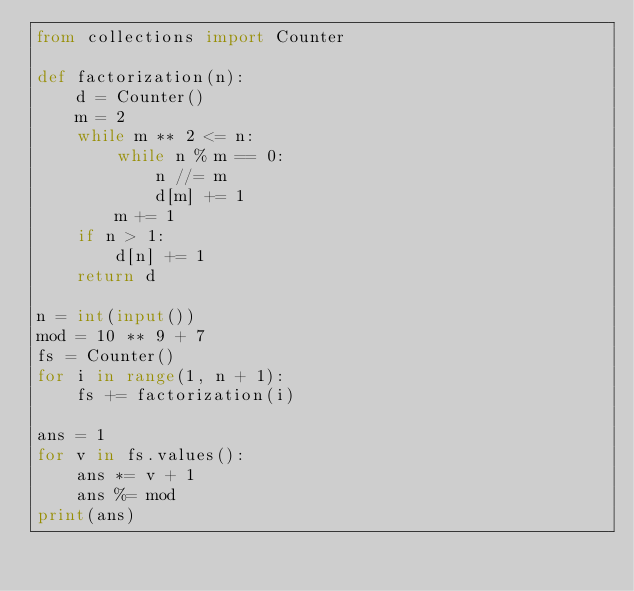Convert code to text. <code><loc_0><loc_0><loc_500><loc_500><_Python_>from collections import Counter

def factorization(n):
    d = Counter()
    m = 2
    while m ** 2 <= n:
        while n % m == 0:
            n //= m
            d[m] += 1
        m += 1
    if n > 1:
        d[n] += 1
    return d

n = int(input())
mod = 10 ** 9 + 7
fs = Counter()
for i in range(1, n + 1):
    fs += factorization(i)

ans = 1
for v in fs.values():
    ans *= v + 1
    ans %= mod
print(ans)
</code> 